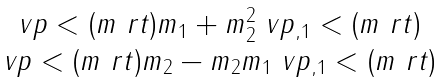<formula> <loc_0><loc_0><loc_500><loc_500>\begin{matrix} \ v p < ( m \ r t ) m _ { 1 } + m _ { 2 } ^ { 2 } \ v p _ { , 1 } < ( m \ r t ) \\ \ v p < ( m \ r t ) m _ { 2 } - m _ { 2 } m _ { 1 } \ v p _ { , 1 } < ( m \ r t ) \end{matrix}</formula> 